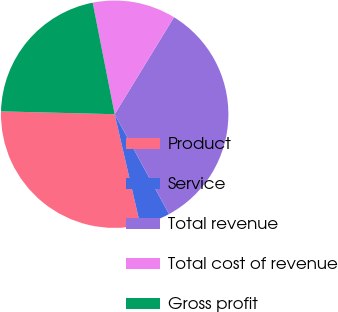<chart> <loc_0><loc_0><loc_500><loc_500><pie_chart><fcel>Product<fcel>Service<fcel>Total revenue<fcel>Total cost of revenue<fcel>Gross profit<nl><fcel>29.01%<fcel>4.32%<fcel>33.33%<fcel>11.83%<fcel>21.5%<nl></chart> 